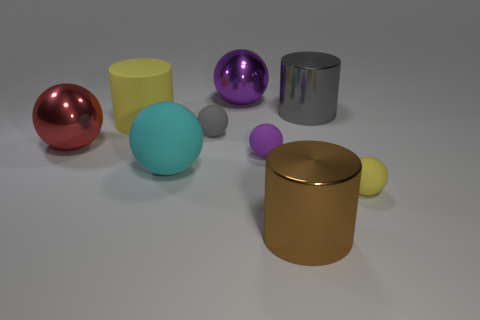How many other things are made of the same material as the small yellow object?
Your response must be concise. 4. There is a object that is to the right of the big brown thing and behind the gray rubber object; what material is it made of?
Your answer should be very brief. Metal. There is a large metallic object that is in front of the tiny purple object; does it have the same shape as the small purple rubber object?
Your response must be concise. No. Are there fewer tiny cyan metallic balls than red objects?
Your answer should be very brief. Yes. How many small spheres are the same color as the rubber cylinder?
Ensure brevity in your answer.  1. There is a thing that is the same color as the big matte cylinder; what is its material?
Keep it short and to the point. Rubber. Does the large rubber cylinder have the same color as the cylinder in front of the large cyan rubber thing?
Your answer should be compact. No. Are there more tiny blue objects than large cyan matte objects?
Provide a succinct answer. No. There is a purple matte object that is the same shape as the cyan thing; what is its size?
Offer a terse response. Small. Do the cyan thing and the tiny yellow sphere in front of the cyan thing have the same material?
Provide a short and direct response. Yes. 